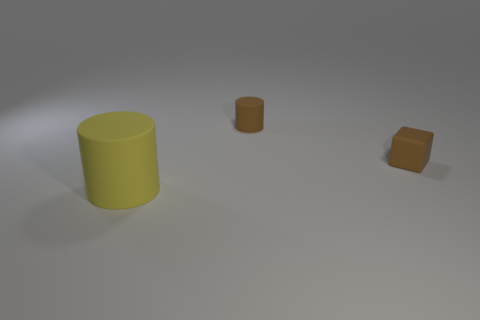Are there any other things that are the same size as the brown cylinder?
Ensure brevity in your answer.  Yes. There is a block that is the same material as the big yellow thing; what color is it?
Make the answer very short. Brown. Are there fewer matte blocks behind the small rubber cylinder than small brown rubber objects that are behind the large yellow object?
Give a very brief answer. Yes. How many matte cylinders are the same color as the large rubber object?
Offer a very short reply. 0. There is a small object that is the same color as the matte cube; what material is it?
Give a very brief answer. Rubber. How many tiny rubber things are both in front of the brown cylinder and to the left of the small brown matte block?
Your response must be concise. 0. The tiny object on the right side of the cylinder that is behind the big matte object is made of what material?
Ensure brevity in your answer.  Rubber. Is there a tiny cyan cylinder made of the same material as the yellow cylinder?
Your answer should be compact. No. There is a object that is the same size as the rubber cube; what material is it?
Make the answer very short. Rubber. There is a thing to the left of the rubber cylinder that is behind the rubber cylinder that is in front of the tiny brown block; how big is it?
Ensure brevity in your answer.  Large. 